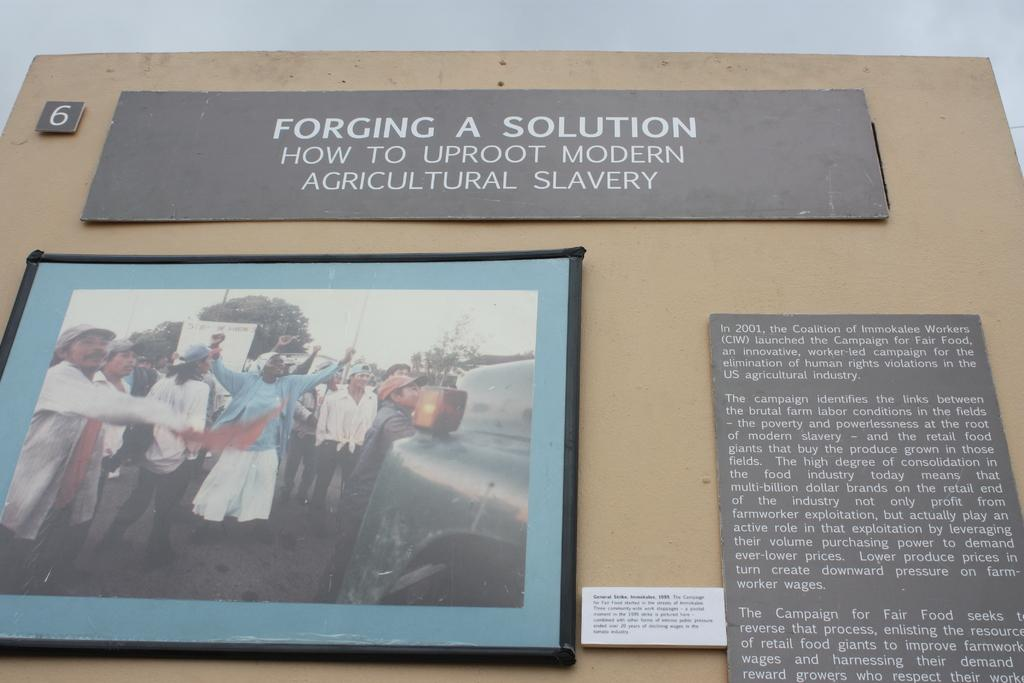<image>
Summarize the visual content of the image. Sign on a wall that says "Forging a Solution" showing people protesting. 